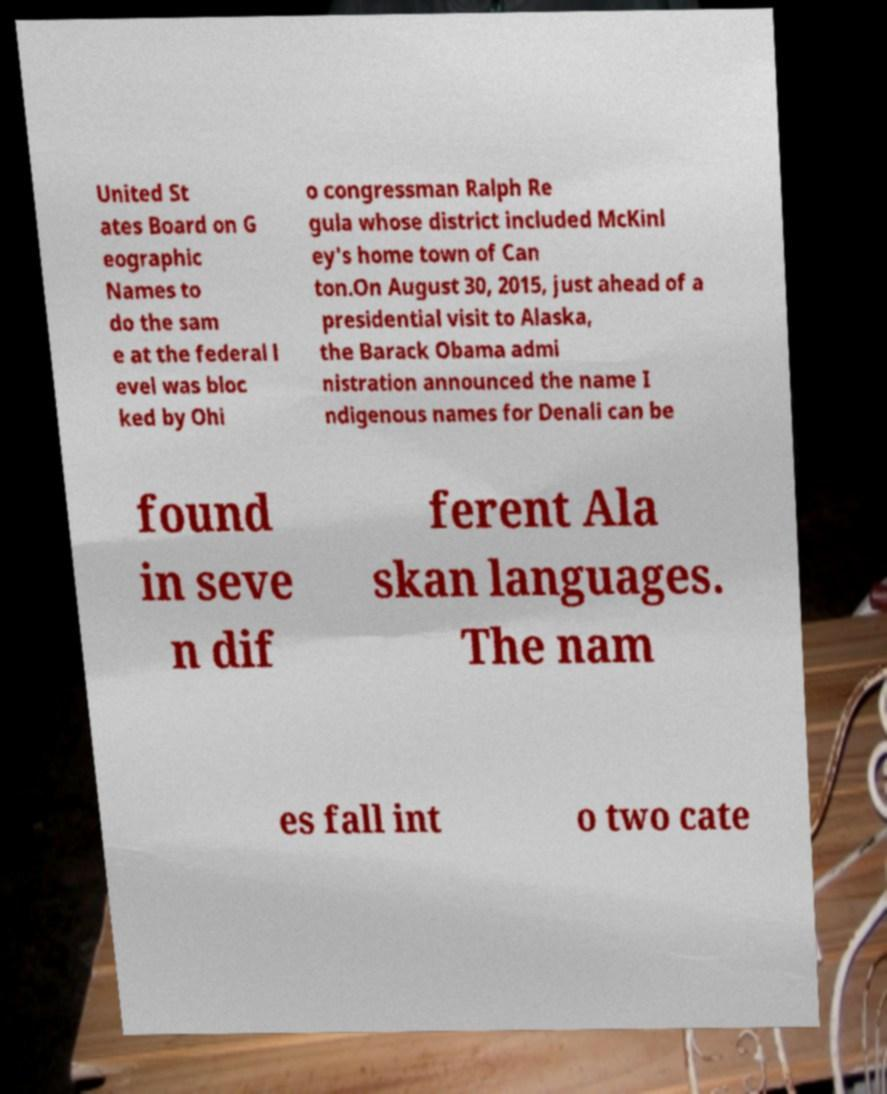Can you read and provide the text displayed in the image?This photo seems to have some interesting text. Can you extract and type it out for me? United St ates Board on G eographic Names to do the sam e at the federal l evel was bloc ked by Ohi o congressman Ralph Re gula whose district included McKinl ey's home town of Can ton.On August 30, 2015, just ahead of a presidential visit to Alaska, the Barack Obama admi nistration announced the name I ndigenous names for Denali can be found in seve n dif ferent Ala skan languages. The nam es fall int o two cate 